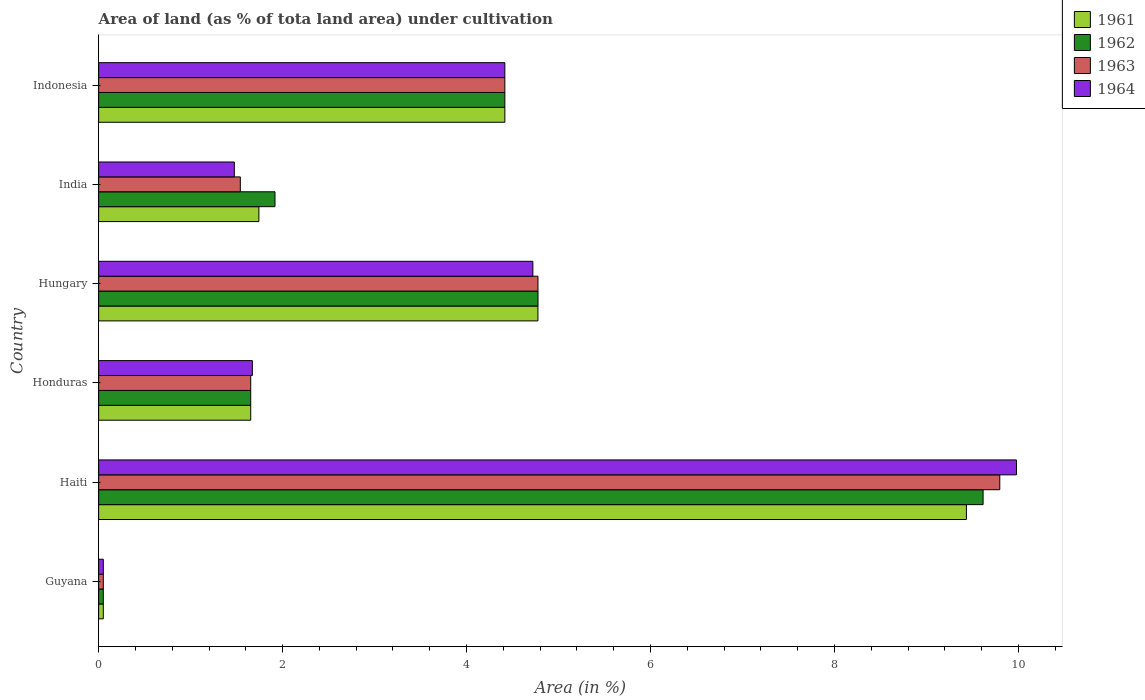Are the number of bars per tick equal to the number of legend labels?
Make the answer very short. Yes. Are the number of bars on each tick of the Y-axis equal?
Give a very brief answer. Yes. How many bars are there on the 5th tick from the top?
Ensure brevity in your answer.  4. What is the label of the 1st group of bars from the top?
Provide a short and direct response. Indonesia. What is the percentage of land under cultivation in 1961 in Guyana?
Make the answer very short. 0.05. Across all countries, what is the maximum percentage of land under cultivation in 1962?
Your answer should be very brief. 9.62. Across all countries, what is the minimum percentage of land under cultivation in 1961?
Keep it short and to the point. 0.05. In which country was the percentage of land under cultivation in 1963 maximum?
Make the answer very short. Haiti. In which country was the percentage of land under cultivation in 1964 minimum?
Provide a short and direct response. Guyana. What is the total percentage of land under cultivation in 1961 in the graph?
Offer a very short reply. 22.07. What is the difference between the percentage of land under cultivation in 1963 in Hungary and that in Indonesia?
Offer a terse response. 0.36. What is the difference between the percentage of land under cultivation in 1964 in India and the percentage of land under cultivation in 1963 in Haiti?
Your answer should be very brief. -8.32. What is the average percentage of land under cultivation in 1964 per country?
Provide a short and direct response. 3.72. What is the difference between the percentage of land under cultivation in 1964 and percentage of land under cultivation in 1963 in Honduras?
Provide a succinct answer. 0.02. What is the ratio of the percentage of land under cultivation in 1964 in Guyana to that in Haiti?
Your response must be concise. 0.01. Is the percentage of land under cultivation in 1961 in Haiti less than that in Indonesia?
Your response must be concise. No. What is the difference between the highest and the second highest percentage of land under cultivation in 1961?
Your answer should be compact. 4.66. What is the difference between the highest and the lowest percentage of land under cultivation in 1962?
Provide a succinct answer. 9.56. In how many countries, is the percentage of land under cultivation in 1963 greater than the average percentage of land under cultivation in 1963 taken over all countries?
Ensure brevity in your answer.  3. Is the sum of the percentage of land under cultivation in 1961 in Hungary and Indonesia greater than the maximum percentage of land under cultivation in 1962 across all countries?
Give a very brief answer. No. What does the 4th bar from the top in Hungary represents?
Offer a very short reply. 1961. Is it the case that in every country, the sum of the percentage of land under cultivation in 1964 and percentage of land under cultivation in 1961 is greater than the percentage of land under cultivation in 1963?
Your answer should be compact. Yes. Are all the bars in the graph horizontal?
Your answer should be compact. Yes. What is the difference between two consecutive major ticks on the X-axis?
Offer a very short reply. 2. How many legend labels are there?
Make the answer very short. 4. What is the title of the graph?
Your answer should be very brief. Area of land (as % of tota land area) under cultivation. What is the label or title of the X-axis?
Keep it short and to the point. Area (in %). What is the label or title of the Y-axis?
Your answer should be compact. Country. What is the Area (in %) of 1961 in Guyana?
Provide a short and direct response. 0.05. What is the Area (in %) in 1962 in Guyana?
Ensure brevity in your answer.  0.05. What is the Area (in %) in 1963 in Guyana?
Offer a very short reply. 0.05. What is the Area (in %) of 1964 in Guyana?
Your answer should be very brief. 0.05. What is the Area (in %) in 1961 in Haiti?
Give a very brief answer. 9.43. What is the Area (in %) of 1962 in Haiti?
Provide a short and direct response. 9.62. What is the Area (in %) of 1963 in Haiti?
Provide a succinct answer. 9.8. What is the Area (in %) in 1964 in Haiti?
Offer a very short reply. 9.98. What is the Area (in %) of 1961 in Honduras?
Provide a succinct answer. 1.65. What is the Area (in %) in 1962 in Honduras?
Offer a terse response. 1.65. What is the Area (in %) in 1963 in Honduras?
Keep it short and to the point. 1.65. What is the Area (in %) of 1964 in Honduras?
Offer a very short reply. 1.67. What is the Area (in %) of 1961 in Hungary?
Offer a terse response. 4.78. What is the Area (in %) in 1962 in Hungary?
Keep it short and to the point. 4.78. What is the Area (in %) in 1963 in Hungary?
Your answer should be very brief. 4.78. What is the Area (in %) in 1964 in Hungary?
Your response must be concise. 4.72. What is the Area (in %) in 1961 in India?
Give a very brief answer. 1.74. What is the Area (in %) of 1962 in India?
Offer a terse response. 1.92. What is the Area (in %) in 1963 in India?
Your answer should be very brief. 1.54. What is the Area (in %) of 1964 in India?
Keep it short and to the point. 1.48. What is the Area (in %) of 1961 in Indonesia?
Offer a very short reply. 4.42. What is the Area (in %) of 1962 in Indonesia?
Your answer should be compact. 4.42. What is the Area (in %) in 1963 in Indonesia?
Ensure brevity in your answer.  4.42. What is the Area (in %) of 1964 in Indonesia?
Make the answer very short. 4.42. Across all countries, what is the maximum Area (in %) in 1961?
Offer a very short reply. 9.43. Across all countries, what is the maximum Area (in %) in 1962?
Offer a very short reply. 9.62. Across all countries, what is the maximum Area (in %) in 1963?
Provide a short and direct response. 9.8. Across all countries, what is the maximum Area (in %) in 1964?
Your response must be concise. 9.98. Across all countries, what is the minimum Area (in %) of 1961?
Give a very brief answer. 0.05. Across all countries, what is the minimum Area (in %) in 1962?
Provide a succinct answer. 0.05. Across all countries, what is the minimum Area (in %) of 1963?
Your answer should be compact. 0.05. Across all countries, what is the minimum Area (in %) in 1964?
Provide a succinct answer. 0.05. What is the total Area (in %) in 1961 in the graph?
Provide a succinct answer. 22.07. What is the total Area (in %) in 1962 in the graph?
Offer a very short reply. 22.43. What is the total Area (in %) of 1963 in the graph?
Your response must be concise. 22.23. What is the total Area (in %) in 1964 in the graph?
Your response must be concise. 22.31. What is the difference between the Area (in %) of 1961 in Guyana and that in Haiti?
Make the answer very short. -9.38. What is the difference between the Area (in %) of 1962 in Guyana and that in Haiti?
Offer a very short reply. -9.56. What is the difference between the Area (in %) in 1963 in Guyana and that in Haiti?
Give a very brief answer. -9.75. What is the difference between the Area (in %) in 1964 in Guyana and that in Haiti?
Your answer should be compact. -9.93. What is the difference between the Area (in %) of 1961 in Guyana and that in Honduras?
Offer a terse response. -1.6. What is the difference between the Area (in %) of 1962 in Guyana and that in Honduras?
Your answer should be compact. -1.6. What is the difference between the Area (in %) of 1963 in Guyana and that in Honduras?
Offer a very short reply. -1.6. What is the difference between the Area (in %) of 1964 in Guyana and that in Honduras?
Make the answer very short. -1.62. What is the difference between the Area (in %) in 1961 in Guyana and that in Hungary?
Keep it short and to the point. -4.72. What is the difference between the Area (in %) in 1962 in Guyana and that in Hungary?
Make the answer very short. -4.73. What is the difference between the Area (in %) in 1963 in Guyana and that in Hungary?
Provide a succinct answer. -4.73. What is the difference between the Area (in %) of 1964 in Guyana and that in Hungary?
Ensure brevity in your answer.  -4.67. What is the difference between the Area (in %) of 1961 in Guyana and that in India?
Make the answer very short. -1.69. What is the difference between the Area (in %) in 1962 in Guyana and that in India?
Provide a short and direct response. -1.87. What is the difference between the Area (in %) of 1963 in Guyana and that in India?
Your answer should be very brief. -1.49. What is the difference between the Area (in %) of 1964 in Guyana and that in India?
Provide a short and direct response. -1.42. What is the difference between the Area (in %) of 1961 in Guyana and that in Indonesia?
Provide a succinct answer. -4.37. What is the difference between the Area (in %) in 1962 in Guyana and that in Indonesia?
Provide a succinct answer. -4.37. What is the difference between the Area (in %) in 1963 in Guyana and that in Indonesia?
Ensure brevity in your answer.  -4.37. What is the difference between the Area (in %) of 1964 in Guyana and that in Indonesia?
Your answer should be very brief. -4.37. What is the difference between the Area (in %) of 1961 in Haiti and that in Honduras?
Offer a very short reply. 7.78. What is the difference between the Area (in %) in 1962 in Haiti and that in Honduras?
Ensure brevity in your answer.  7.96. What is the difference between the Area (in %) of 1963 in Haiti and that in Honduras?
Your answer should be compact. 8.14. What is the difference between the Area (in %) in 1964 in Haiti and that in Honduras?
Keep it short and to the point. 8.31. What is the difference between the Area (in %) of 1961 in Haiti and that in Hungary?
Keep it short and to the point. 4.66. What is the difference between the Area (in %) in 1962 in Haiti and that in Hungary?
Make the answer very short. 4.84. What is the difference between the Area (in %) of 1963 in Haiti and that in Hungary?
Make the answer very short. 5.02. What is the difference between the Area (in %) in 1964 in Haiti and that in Hungary?
Your answer should be very brief. 5.26. What is the difference between the Area (in %) of 1961 in Haiti and that in India?
Offer a terse response. 7.69. What is the difference between the Area (in %) of 1962 in Haiti and that in India?
Offer a terse response. 7.7. What is the difference between the Area (in %) in 1963 in Haiti and that in India?
Offer a very short reply. 8.26. What is the difference between the Area (in %) in 1964 in Haiti and that in India?
Ensure brevity in your answer.  8.5. What is the difference between the Area (in %) in 1961 in Haiti and that in Indonesia?
Make the answer very short. 5.02. What is the difference between the Area (in %) in 1962 in Haiti and that in Indonesia?
Your response must be concise. 5.2. What is the difference between the Area (in %) of 1963 in Haiti and that in Indonesia?
Ensure brevity in your answer.  5.38. What is the difference between the Area (in %) of 1964 in Haiti and that in Indonesia?
Offer a very short reply. 5.56. What is the difference between the Area (in %) in 1961 in Honduras and that in Hungary?
Your answer should be very brief. -3.12. What is the difference between the Area (in %) in 1962 in Honduras and that in Hungary?
Keep it short and to the point. -3.12. What is the difference between the Area (in %) of 1963 in Honduras and that in Hungary?
Keep it short and to the point. -3.12. What is the difference between the Area (in %) in 1964 in Honduras and that in Hungary?
Give a very brief answer. -3.05. What is the difference between the Area (in %) of 1961 in Honduras and that in India?
Your response must be concise. -0.09. What is the difference between the Area (in %) of 1962 in Honduras and that in India?
Your response must be concise. -0.26. What is the difference between the Area (in %) of 1963 in Honduras and that in India?
Make the answer very short. 0.11. What is the difference between the Area (in %) in 1964 in Honduras and that in India?
Your answer should be very brief. 0.2. What is the difference between the Area (in %) of 1961 in Honduras and that in Indonesia?
Offer a terse response. -2.76. What is the difference between the Area (in %) in 1962 in Honduras and that in Indonesia?
Your answer should be compact. -2.76. What is the difference between the Area (in %) of 1963 in Honduras and that in Indonesia?
Your response must be concise. -2.76. What is the difference between the Area (in %) in 1964 in Honduras and that in Indonesia?
Offer a very short reply. -2.74. What is the difference between the Area (in %) in 1961 in Hungary and that in India?
Provide a short and direct response. 3.03. What is the difference between the Area (in %) of 1962 in Hungary and that in India?
Ensure brevity in your answer.  2.86. What is the difference between the Area (in %) in 1963 in Hungary and that in India?
Your answer should be very brief. 3.24. What is the difference between the Area (in %) in 1964 in Hungary and that in India?
Offer a terse response. 3.25. What is the difference between the Area (in %) of 1961 in Hungary and that in Indonesia?
Make the answer very short. 0.36. What is the difference between the Area (in %) in 1962 in Hungary and that in Indonesia?
Ensure brevity in your answer.  0.36. What is the difference between the Area (in %) in 1963 in Hungary and that in Indonesia?
Keep it short and to the point. 0.36. What is the difference between the Area (in %) in 1964 in Hungary and that in Indonesia?
Offer a very short reply. 0.3. What is the difference between the Area (in %) of 1961 in India and that in Indonesia?
Give a very brief answer. -2.67. What is the difference between the Area (in %) in 1962 in India and that in Indonesia?
Your response must be concise. -2.5. What is the difference between the Area (in %) in 1963 in India and that in Indonesia?
Your response must be concise. -2.88. What is the difference between the Area (in %) of 1964 in India and that in Indonesia?
Give a very brief answer. -2.94. What is the difference between the Area (in %) in 1961 in Guyana and the Area (in %) in 1962 in Haiti?
Ensure brevity in your answer.  -9.56. What is the difference between the Area (in %) in 1961 in Guyana and the Area (in %) in 1963 in Haiti?
Provide a succinct answer. -9.75. What is the difference between the Area (in %) of 1961 in Guyana and the Area (in %) of 1964 in Haiti?
Provide a short and direct response. -9.93. What is the difference between the Area (in %) of 1962 in Guyana and the Area (in %) of 1963 in Haiti?
Your answer should be very brief. -9.75. What is the difference between the Area (in %) of 1962 in Guyana and the Area (in %) of 1964 in Haiti?
Give a very brief answer. -9.93. What is the difference between the Area (in %) of 1963 in Guyana and the Area (in %) of 1964 in Haiti?
Make the answer very short. -9.93. What is the difference between the Area (in %) in 1961 in Guyana and the Area (in %) in 1962 in Honduras?
Your answer should be compact. -1.6. What is the difference between the Area (in %) of 1961 in Guyana and the Area (in %) of 1963 in Honduras?
Your answer should be very brief. -1.6. What is the difference between the Area (in %) of 1961 in Guyana and the Area (in %) of 1964 in Honduras?
Your response must be concise. -1.62. What is the difference between the Area (in %) of 1962 in Guyana and the Area (in %) of 1963 in Honduras?
Your response must be concise. -1.6. What is the difference between the Area (in %) of 1962 in Guyana and the Area (in %) of 1964 in Honduras?
Give a very brief answer. -1.62. What is the difference between the Area (in %) of 1963 in Guyana and the Area (in %) of 1964 in Honduras?
Provide a succinct answer. -1.62. What is the difference between the Area (in %) in 1961 in Guyana and the Area (in %) in 1962 in Hungary?
Your answer should be compact. -4.73. What is the difference between the Area (in %) in 1961 in Guyana and the Area (in %) in 1963 in Hungary?
Your answer should be compact. -4.73. What is the difference between the Area (in %) in 1961 in Guyana and the Area (in %) in 1964 in Hungary?
Make the answer very short. -4.67. What is the difference between the Area (in %) of 1962 in Guyana and the Area (in %) of 1963 in Hungary?
Make the answer very short. -4.73. What is the difference between the Area (in %) in 1962 in Guyana and the Area (in %) in 1964 in Hungary?
Give a very brief answer. -4.67. What is the difference between the Area (in %) in 1963 in Guyana and the Area (in %) in 1964 in Hungary?
Your answer should be compact. -4.67. What is the difference between the Area (in %) in 1961 in Guyana and the Area (in %) in 1962 in India?
Make the answer very short. -1.87. What is the difference between the Area (in %) of 1961 in Guyana and the Area (in %) of 1963 in India?
Give a very brief answer. -1.49. What is the difference between the Area (in %) of 1961 in Guyana and the Area (in %) of 1964 in India?
Your response must be concise. -1.42. What is the difference between the Area (in %) in 1962 in Guyana and the Area (in %) in 1963 in India?
Give a very brief answer. -1.49. What is the difference between the Area (in %) of 1962 in Guyana and the Area (in %) of 1964 in India?
Give a very brief answer. -1.42. What is the difference between the Area (in %) of 1963 in Guyana and the Area (in %) of 1964 in India?
Provide a short and direct response. -1.42. What is the difference between the Area (in %) of 1961 in Guyana and the Area (in %) of 1962 in Indonesia?
Offer a terse response. -4.37. What is the difference between the Area (in %) of 1961 in Guyana and the Area (in %) of 1963 in Indonesia?
Your answer should be very brief. -4.37. What is the difference between the Area (in %) of 1961 in Guyana and the Area (in %) of 1964 in Indonesia?
Your response must be concise. -4.37. What is the difference between the Area (in %) of 1962 in Guyana and the Area (in %) of 1963 in Indonesia?
Your answer should be very brief. -4.37. What is the difference between the Area (in %) in 1962 in Guyana and the Area (in %) in 1964 in Indonesia?
Make the answer very short. -4.37. What is the difference between the Area (in %) of 1963 in Guyana and the Area (in %) of 1964 in Indonesia?
Keep it short and to the point. -4.37. What is the difference between the Area (in %) of 1961 in Haiti and the Area (in %) of 1962 in Honduras?
Provide a succinct answer. 7.78. What is the difference between the Area (in %) in 1961 in Haiti and the Area (in %) in 1963 in Honduras?
Give a very brief answer. 7.78. What is the difference between the Area (in %) of 1961 in Haiti and the Area (in %) of 1964 in Honduras?
Keep it short and to the point. 7.76. What is the difference between the Area (in %) in 1962 in Haiti and the Area (in %) in 1963 in Honduras?
Ensure brevity in your answer.  7.96. What is the difference between the Area (in %) in 1962 in Haiti and the Area (in %) in 1964 in Honduras?
Provide a succinct answer. 7.94. What is the difference between the Area (in %) in 1963 in Haiti and the Area (in %) in 1964 in Honduras?
Offer a very short reply. 8.13. What is the difference between the Area (in %) in 1961 in Haiti and the Area (in %) in 1962 in Hungary?
Make the answer very short. 4.66. What is the difference between the Area (in %) in 1961 in Haiti and the Area (in %) in 1963 in Hungary?
Your answer should be compact. 4.66. What is the difference between the Area (in %) of 1961 in Haiti and the Area (in %) of 1964 in Hungary?
Ensure brevity in your answer.  4.71. What is the difference between the Area (in %) in 1962 in Haiti and the Area (in %) in 1963 in Hungary?
Your response must be concise. 4.84. What is the difference between the Area (in %) in 1962 in Haiti and the Area (in %) in 1964 in Hungary?
Provide a short and direct response. 4.89. What is the difference between the Area (in %) of 1963 in Haiti and the Area (in %) of 1964 in Hungary?
Provide a succinct answer. 5.08. What is the difference between the Area (in %) in 1961 in Haiti and the Area (in %) in 1962 in India?
Provide a succinct answer. 7.52. What is the difference between the Area (in %) of 1961 in Haiti and the Area (in %) of 1963 in India?
Provide a short and direct response. 7.89. What is the difference between the Area (in %) of 1961 in Haiti and the Area (in %) of 1964 in India?
Keep it short and to the point. 7.96. What is the difference between the Area (in %) of 1962 in Haiti and the Area (in %) of 1963 in India?
Provide a short and direct response. 8.07. What is the difference between the Area (in %) of 1962 in Haiti and the Area (in %) of 1964 in India?
Provide a short and direct response. 8.14. What is the difference between the Area (in %) of 1963 in Haiti and the Area (in %) of 1964 in India?
Ensure brevity in your answer.  8.32. What is the difference between the Area (in %) of 1961 in Haiti and the Area (in %) of 1962 in Indonesia?
Your response must be concise. 5.02. What is the difference between the Area (in %) of 1961 in Haiti and the Area (in %) of 1963 in Indonesia?
Offer a very short reply. 5.02. What is the difference between the Area (in %) in 1961 in Haiti and the Area (in %) in 1964 in Indonesia?
Your answer should be very brief. 5.02. What is the difference between the Area (in %) in 1962 in Haiti and the Area (in %) in 1963 in Indonesia?
Your answer should be very brief. 5.2. What is the difference between the Area (in %) of 1962 in Haiti and the Area (in %) of 1964 in Indonesia?
Provide a short and direct response. 5.2. What is the difference between the Area (in %) of 1963 in Haiti and the Area (in %) of 1964 in Indonesia?
Make the answer very short. 5.38. What is the difference between the Area (in %) in 1961 in Honduras and the Area (in %) in 1962 in Hungary?
Offer a very short reply. -3.12. What is the difference between the Area (in %) of 1961 in Honduras and the Area (in %) of 1963 in Hungary?
Provide a short and direct response. -3.12. What is the difference between the Area (in %) in 1961 in Honduras and the Area (in %) in 1964 in Hungary?
Make the answer very short. -3.07. What is the difference between the Area (in %) in 1962 in Honduras and the Area (in %) in 1963 in Hungary?
Your answer should be compact. -3.12. What is the difference between the Area (in %) in 1962 in Honduras and the Area (in %) in 1964 in Hungary?
Make the answer very short. -3.07. What is the difference between the Area (in %) in 1963 in Honduras and the Area (in %) in 1964 in Hungary?
Keep it short and to the point. -3.07. What is the difference between the Area (in %) of 1961 in Honduras and the Area (in %) of 1962 in India?
Your response must be concise. -0.26. What is the difference between the Area (in %) of 1961 in Honduras and the Area (in %) of 1963 in India?
Offer a terse response. 0.11. What is the difference between the Area (in %) of 1961 in Honduras and the Area (in %) of 1964 in India?
Offer a very short reply. 0.18. What is the difference between the Area (in %) in 1962 in Honduras and the Area (in %) in 1963 in India?
Provide a succinct answer. 0.11. What is the difference between the Area (in %) in 1962 in Honduras and the Area (in %) in 1964 in India?
Offer a very short reply. 0.18. What is the difference between the Area (in %) of 1963 in Honduras and the Area (in %) of 1964 in India?
Your answer should be compact. 0.18. What is the difference between the Area (in %) in 1961 in Honduras and the Area (in %) in 1962 in Indonesia?
Your answer should be very brief. -2.76. What is the difference between the Area (in %) of 1961 in Honduras and the Area (in %) of 1963 in Indonesia?
Offer a terse response. -2.76. What is the difference between the Area (in %) in 1961 in Honduras and the Area (in %) in 1964 in Indonesia?
Your answer should be very brief. -2.76. What is the difference between the Area (in %) in 1962 in Honduras and the Area (in %) in 1963 in Indonesia?
Your answer should be very brief. -2.76. What is the difference between the Area (in %) in 1962 in Honduras and the Area (in %) in 1964 in Indonesia?
Offer a very short reply. -2.76. What is the difference between the Area (in %) in 1963 in Honduras and the Area (in %) in 1964 in Indonesia?
Provide a short and direct response. -2.76. What is the difference between the Area (in %) in 1961 in Hungary and the Area (in %) in 1962 in India?
Your answer should be very brief. 2.86. What is the difference between the Area (in %) of 1961 in Hungary and the Area (in %) of 1963 in India?
Offer a terse response. 3.24. What is the difference between the Area (in %) in 1961 in Hungary and the Area (in %) in 1964 in India?
Provide a succinct answer. 3.3. What is the difference between the Area (in %) of 1962 in Hungary and the Area (in %) of 1963 in India?
Give a very brief answer. 3.24. What is the difference between the Area (in %) of 1962 in Hungary and the Area (in %) of 1964 in India?
Your answer should be very brief. 3.3. What is the difference between the Area (in %) in 1963 in Hungary and the Area (in %) in 1964 in India?
Your answer should be very brief. 3.3. What is the difference between the Area (in %) of 1961 in Hungary and the Area (in %) of 1962 in Indonesia?
Your answer should be very brief. 0.36. What is the difference between the Area (in %) in 1961 in Hungary and the Area (in %) in 1963 in Indonesia?
Offer a terse response. 0.36. What is the difference between the Area (in %) of 1961 in Hungary and the Area (in %) of 1964 in Indonesia?
Give a very brief answer. 0.36. What is the difference between the Area (in %) in 1962 in Hungary and the Area (in %) in 1963 in Indonesia?
Ensure brevity in your answer.  0.36. What is the difference between the Area (in %) in 1962 in Hungary and the Area (in %) in 1964 in Indonesia?
Give a very brief answer. 0.36. What is the difference between the Area (in %) of 1963 in Hungary and the Area (in %) of 1964 in Indonesia?
Your response must be concise. 0.36. What is the difference between the Area (in %) of 1961 in India and the Area (in %) of 1962 in Indonesia?
Ensure brevity in your answer.  -2.67. What is the difference between the Area (in %) of 1961 in India and the Area (in %) of 1963 in Indonesia?
Offer a very short reply. -2.67. What is the difference between the Area (in %) in 1961 in India and the Area (in %) in 1964 in Indonesia?
Provide a short and direct response. -2.67. What is the difference between the Area (in %) in 1962 in India and the Area (in %) in 1963 in Indonesia?
Keep it short and to the point. -2.5. What is the difference between the Area (in %) of 1962 in India and the Area (in %) of 1964 in Indonesia?
Your answer should be compact. -2.5. What is the difference between the Area (in %) in 1963 in India and the Area (in %) in 1964 in Indonesia?
Make the answer very short. -2.88. What is the average Area (in %) in 1961 per country?
Ensure brevity in your answer.  3.68. What is the average Area (in %) of 1962 per country?
Your response must be concise. 3.74. What is the average Area (in %) in 1963 per country?
Offer a terse response. 3.71. What is the average Area (in %) of 1964 per country?
Ensure brevity in your answer.  3.72. What is the difference between the Area (in %) in 1961 and Area (in %) in 1963 in Guyana?
Offer a terse response. 0. What is the difference between the Area (in %) of 1961 and Area (in %) of 1964 in Guyana?
Provide a succinct answer. 0. What is the difference between the Area (in %) in 1963 and Area (in %) in 1964 in Guyana?
Make the answer very short. 0. What is the difference between the Area (in %) of 1961 and Area (in %) of 1962 in Haiti?
Your answer should be compact. -0.18. What is the difference between the Area (in %) in 1961 and Area (in %) in 1963 in Haiti?
Your answer should be compact. -0.36. What is the difference between the Area (in %) of 1961 and Area (in %) of 1964 in Haiti?
Offer a terse response. -0.54. What is the difference between the Area (in %) of 1962 and Area (in %) of 1963 in Haiti?
Keep it short and to the point. -0.18. What is the difference between the Area (in %) of 1962 and Area (in %) of 1964 in Haiti?
Offer a very short reply. -0.36. What is the difference between the Area (in %) in 1963 and Area (in %) in 1964 in Haiti?
Provide a short and direct response. -0.18. What is the difference between the Area (in %) in 1961 and Area (in %) in 1963 in Honduras?
Make the answer very short. 0. What is the difference between the Area (in %) in 1961 and Area (in %) in 1964 in Honduras?
Offer a terse response. -0.02. What is the difference between the Area (in %) in 1962 and Area (in %) in 1963 in Honduras?
Provide a short and direct response. 0. What is the difference between the Area (in %) in 1962 and Area (in %) in 1964 in Honduras?
Your answer should be very brief. -0.02. What is the difference between the Area (in %) in 1963 and Area (in %) in 1964 in Honduras?
Keep it short and to the point. -0.02. What is the difference between the Area (in %) of 1961 and Area (in %) of 1962 in Hungary?
Ensure brevity in your answer.  -0. What is the difference between the Area (in %) of 1961 and Area (in %) of 1963 in Hungary?
Your answer should be very brief. -0. What is the difference between the Area (in %) of 1961 and Area (in %) of 1964 in Hungary?
Provide a short and direct response. 0.06. What is the difference between the Area (in %) of 1962 and Area (in %) of 1964 in Hungary?
Your answer should be compact. 0.06. What is the difference between the Area (in %) in 1963 and Area (in %) in 1964 in Hungary?
Keep it short and to the point. 0.06. What is the difference between the Area (in %) in 1961 and Area (in %) in 1962 in India?
Your answer should be very brief. -0.17. What is the difference between the Area (in %) of 1961 and Area (in %) of 1963 in India?
Offer a terse response. 0.2. What is the difference between the Area (in %) of 1961 and Area (in %) of 1964 in India?
Provide a short and direct response. 0.27. What is the difference between the Area (in %) of 1962 and Area (in %) of 1963 in India?
Provide a succinct answer. 0.38. What is the difference between the Area (in %) of 1962 and Area (in %) of 1964 in India?
Provide a succinct answer. 0.44. What is the difference between the Area (in %) in 1963 and Area (in %) in 1964 in India?
Your answer should be very brief. 0.07. What is the difference between the Area (in %) of 1961 and Area (in %) of 1962 in Indonesia?
Give a very brief answer. 0. What is the difference between the Area (in %) in 1961 and Area (in %) in 1964 in Indonesia?
Your answer should be compact. 0. What is the difference between the Area (in %) in 1962 and Area (in %) in 1964 in Indonesia?
Offer a very short reply. 0. What is the difference between the Area (in %) of 1963 and Area (in %) of 1964 in Indonesia?
Offer a very short reply. 0. What is the ratio of the Area (in %) of 1961 in Guyana to that in Haiti?
Give a very brief answer. 0.01. What is the ratio of the Area (in %) in 1962 in Guyana to that in Haiti?
Keep it short and to the point. 0.01. What is the ratio of the Area (in %) of 1963 in Guyana to that in Haiti?
Provide a short and direct response. 0.01. What is the ratio of the Area (in %) in 1964 in Guyana to that in Haiti?
Your answer should be very brief. 0.01. What is the ratio of the Area (in %) in 1961 in Guyana to that in Honduras?
Your answer should be compact. 0.03. What is the ratio of the Area (in %) of 1962 in Guyana to that in Honduras?
Provide a succinct answer. 0.03. What is the ratio of the Area (in %) of 1963 in Guyana to that in Honduras?
Offer a very short reply. 0.03. What is the ratio of the Area (in %) of 1964 in Guyana to that in Honduras?
Offer a very short reply. 0.03. What is the ratio of the Area (in %) of 1961 in Guyana to that in Hungary?
Your response must be concise. 0.01. What is the ratio of the Area (in %) in 1962 in Guyana to that in Hungary?
Your answer should be compact. 0.01. What is the ratio of the Area (in %) of 1963 in Guyana to that in Hungary?
Keep it short and to the point. 0.01. What is the ratio of the Area (in %) in 1964 in Guyana to that in Hungary?
Offer a very short reply. 0.01. What is the ratio of the Area (in %) in 1961 in Guyana to that in India?
Offer a terse response. 0.03. What is the ratio of the Area (in %) in 1962 in Guyana to that in India?
Give a very brief answer. 0.03. What is the ratio of the Area (in %) in 1963 in Guyana to that in India?
Your response must be concise. 0.03. What is the ratio of the Area (in %) in 1964 in Guyana to that in India?
Your answer should be compact. 0.03. What is the ratio of the Area (in %) of 1961 in Guyana to that in Indonesia?
Ensure brevity in your answer.  0.01. What is the ratio of the Area (in %) of 1962 in Guyana to that in Indonesia?
Ensure brevity in your answer.  0.01. What is the ratio of the Area (in %) of 1963 in Guyana to that in Indonesia?
Give a very brief answer. 0.01. What is the ratio of the Area (in %) in 1964 in Guyana to that in Indonesia?
Your answer should be very brief. 0.01. What is the ratio of the Area (in %) of 1961 in Haiti to that in Honduras?
Keep it short and to the point. 5.71. What is the ratio of the Area (in %) in 1962 in Haiti to that in Honduras?
Offer a very short reply. 5.82. What is the ratio of the Area (in %) in 1963 in Haiti to that in Honduras?
Offer a very short reply. 5.93. What is the ratio of the Area (in %) of 1964 in Haiti to that in Honduras?
Your answer should be very brief. 5.97. What is the ratio of the Area (in %) of 1961 in Haiti to that in Hungary?
Offer a very short reply. 1.98. What is the ratio of the Area (in %) of 1962 in Haiti to that in Hungary?
Your response must be concise. 2.01. What is the ratio of the Area (in %) of 1963 in Haiti to that in Hungary?
Your response must be concise. 2.05. What is the ratio of the Area (in %) in 1964 in Haiti to that in Hungary?
Provide a succinct answer. 2.11. What is the ratio of the Area (in %) in 1961 in Haiti to that in India?
Ensure brevity in your answer.  5.41. What is the ratio of the Area (in %) of 1962 in Haiti to that in India?
Offer a terse response. 5.02. What is the ratio of the Area (in %) of 1963 in Haiti to that in India?
Offer a very short reply. 6.36. What is the ratio of the Area (in %) in 1964 in Haiti to that in India?
Make the answer very short. 6.76. What is the ratio of the Area (in %) of 1961 in Haiti to that in Indonesia?
Give a very brief answer. 2.14. What is the ratio of the Area (in %) of 1962 in Haiti to that in Indonesia?
Ensure brevity in your answer.  2.18. What is the ratio of the Area (in %) in 1963 in Haiti to that in Indonesia?
Make the answer very short. 2.22. What is the ratio of the Area (in %) in 1964 in Haiti to that in Indonesia?
Your response must be concise. 2.26. What is the ratio of the Area (in %) in 1961 in Honduras to that in Hungary?
Your answer should be compact. 0.35. What is the ratio of the Area (in %) of 1962 in Honduras to that in Hungary?
Your answer should be very brief. 0.35. What is the ratio of the Area (in %) in 1963 in Honduras to that in Hungary?
Your response must be concise. 0.35. What is the ratio of the Area (in %) in 1964 in Honduras to that in Hungary?
Provide a succinct answer. 0.35. What is the ratio of the Area (in %) of 1961 in Honduras to that in India?
Your response must be concise. 0.95. What is the ratio of the Area (in %) in 1962 in Honduras to that in India?
Offer a terse response. 0.86. What is the ratio of the Area (in %) of 1963 in Honduras to that in India?
Provide a short and direct response. 1.07. What is the ratio of the Area (in %) of 1964 in Honduras to that in India?
Provide a succinct answer. 1.13. What is the ratio of the Area (in %) in 1961 in Honduras to that in Indonesia?
Provide a short and direct response. 0.37. What is the ratio of the Area (in %) of 1962 in Honduras to that in Indonesia?
Your answer should be compact. 0.37. What is the ratio of the Area (in %) in 1963 in Honduras to that in Indonesia?
Offer a very short reply. 0.37. What is the ratio of the Area (in %) of 1964 in Honduras to that in Indonesia?
Offer a terse response. 0.38. What is the ratio of the Area (in %) of 1961 in Hungary to that in India?
Provide a succinct answer. 2.74. What is the ratio of the Area (in %) of 1962 in Hungary to that in India?
Your response must be concise. 2.49. What is the ratio of the Area (in %) in 1963 in Hungary to that in India?
Provide a succinct answer. 3.1. What is the ratio of the Area (in %) in 1964 in Hungary to that in India?
Give a very brief answer. 3.2. What is the ratio of the Area (in %) in 1961 in Hungary to that in Indonesia?
Your response must be concise. 1.08. What is the ratio of the Area (in %) of 1962 in Hungary to that in Indonesia?
Make the answer very short. 1.08. What is the ratio of the Area (in %) of 1963 in Hungary to that in Indonesia?
Your answer should be very brief. 1.08. What is the ratio of the Area (in %) of 1964 in Hungary to that in Indonesia?
Offer a very short reply. 1.07. What is the ratio of the Area (in %) in 1961 in India to that in Indonesia?
Ensure brevity in your answer.  0.39. What is the ratio of the Area (in %) in 1962 in India to that in Indonesia?
Your answer should be compact. 0.43. What is the ratio of the Area (in %) in 1963 in India to that in Indonesia?
Give a very brief answer. 0.35. What is the ratio of the Area (in %) in 1964 in India to that in Indonesia?
Ensure brevity in your answer.  0.33. What is the difference between the highest and the second highest Area (in %) in 1961?
Your response must be concise. 4.66. What is the difference between the highest and the second highest Area (in %) of 1962?
Ensure brevity in your answer.  4.84. What is the difference between the highest and the second highest Area (in %) of 1963?
Give a very brief answer. 5.02. What is the difference between the highest and the second highest Area (in %) in 1964?
Your answer should be very brief. 5.26. What is the difference between the highest and the lowest Area (in %) of 1961?
Offer a terse response. 9.38. What is the difference between the highest and the lowest Area (in %) in 1962?
Your answer should be compact. 9.56. What is the difference between the highest and the lowest Area (in %) in 1963?
Offer a terse response. 9.75. What is the difference between the highest and the lowest Area (in %) in 1964?
Your answer should be compact. 9.93. 